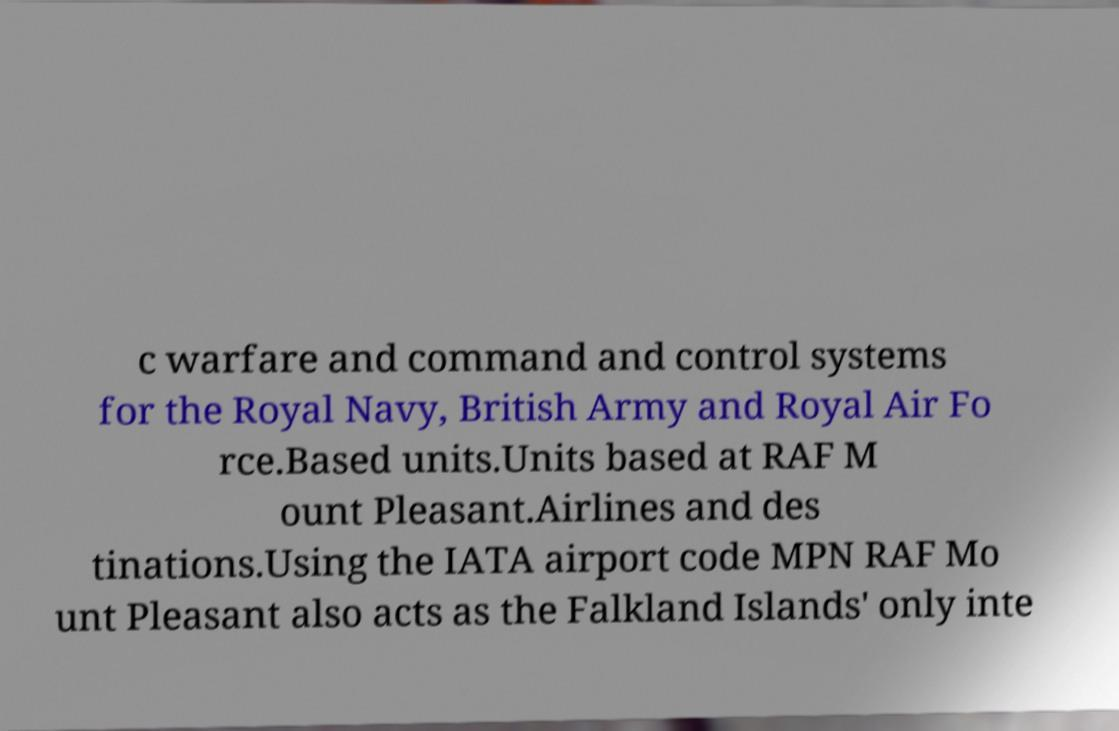Please identify and transcribe the text found in this image. c warfare and command and control systems for the Royal Navy, British Army and Royal Air Fo rce.Based units.Units based at RAF M ount Pleasant.Airlines and des tinations.Using the IATA airport code MPN RAF Mo unt Pleasant also acts as the Falkland Islands' only inte 